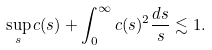<formula> <loc_0><loc_0><loc_500><loc_500>\sup _ { s } c ( s ) + \int _ { 0 } ^ { \infty } c ( s ) ^ { 2 } \frac { d s } { s } \lesssim 1 .</formula> 